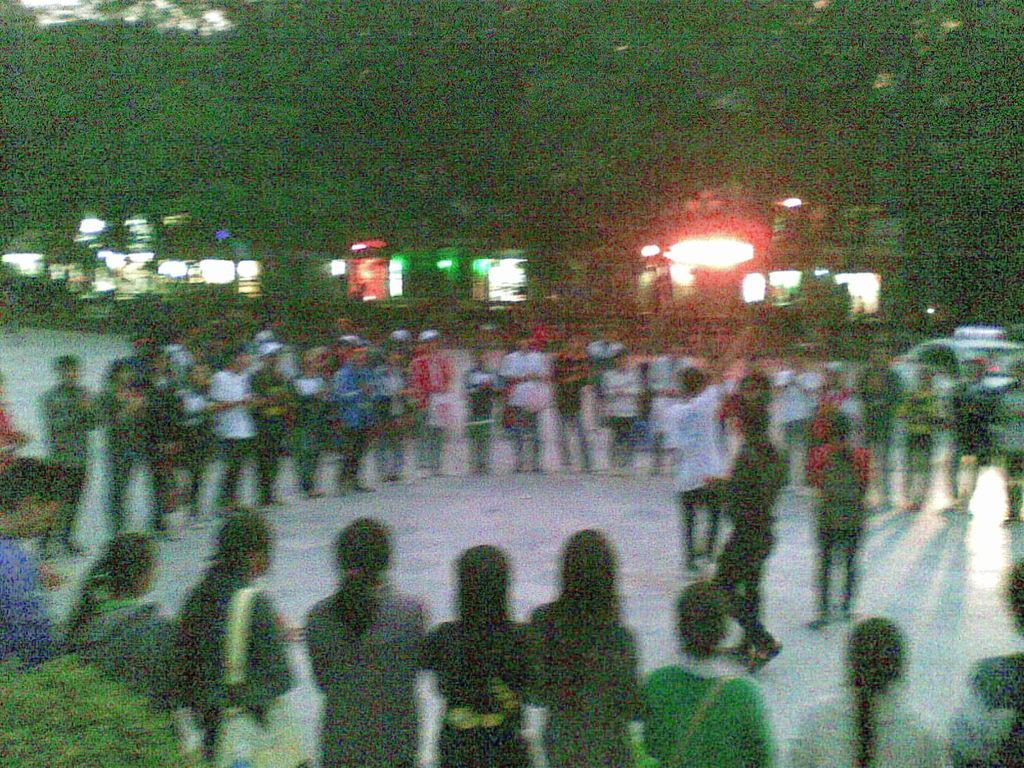What can be seen on the road in the image? There are people on the road in the image. What type of natural elements are present in the image? There are trees and plants in the image. What structures can be seen in the image? There are windows visible in the image. Is there a bomb hidden among the plants in the image? There is no indication of a bomb in the image; it only features people, trees, plants, and windows. What type of flowers can be seen growing near the trees in the image? There are no flowers mentioned or visible in the image. 